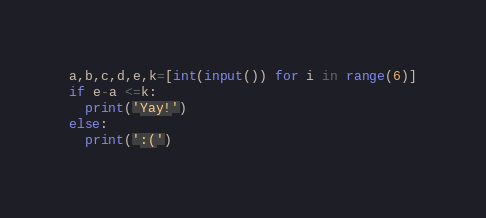<code> <loc_0><loc_0><loc_500><loc_500><_Python_>a,b,c,d,e,k=[int(input()) for i in range(6)]
if e-a <=k:
  print('Yay!')
else:
  print(':(')</code> 